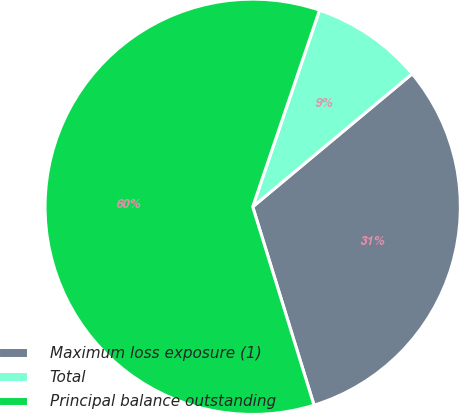Convert chart. <chart><loc_0><loc_0><loc_500><loc_500><pie_chart><fcel>Maximum loss exposure (1)<fcel>Total<fcel>Principal balance outstanding<nl><fcel>31.29%<fcel>8.72%<fcel>59.98%<nl></chart> 